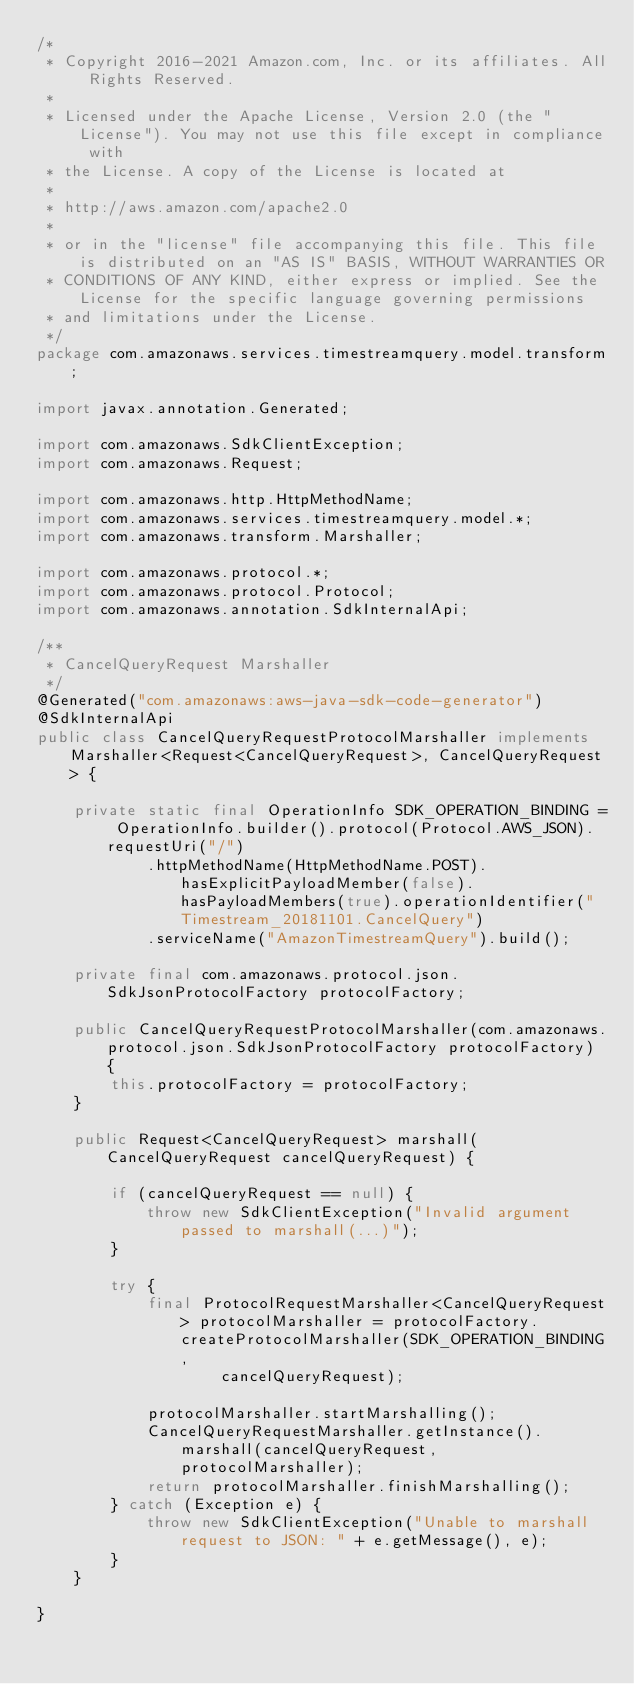Convert code to text. <code><loc_0><loc_0><loc_500><loc_500><_Java_>/*
 * Copyright 2016-2021 Amazon.com, Inc. or its affiliates. All Rights Reserved.
 * 
 * Licensed under the Apache License, Version 2.0 (the "License"). You may not use this file except in compliance with
 * the License. A copy of the License is located at
 * 
 * http://aws.amazon.com/apache2.0
 * 
 * or in the "license" file accompanying this file. This file is distributed on an "AS IS" BASIS, WITHOUT WARRANTIES OR
 * CONDITIONS OF ANY KIND, either express or implied. See the License for the specific language governing permissions
 * and limitations under the License.
 */
package com.amazonaws.services.timestreamquery.model.transform;

import javax.annotation.Generated;

import com.amazonaws.SdkClientException;
import com.amazonaws.Request;

import com.amazonaws.http.HttpMethodName;
import com.amazonaws.services.timestreamquery.model.*;
import com.amazonaws.transform.Marshaller;

import com.amazonaws.protocol.*;
import com.amazonaws.protocol.Protocol;
import com.amazonaws.annotation.SdkInternalApi;

/**
 * CancelQueryRequest Marshaller
 */
@Generated("com.amazonaws:aws-java-sdk-code-generator")
@SdkInternalApi
public class CancelQueryRequestProtocolMarshaller implements Marshaller<Request<CancelQueryRequest>, CancelQueryRequest> {

    private static final OperationInfo SDK_OPERATION_BINDING = OperationInfo.builder().protocol(Protocol.AWS_JSON).requestUri("/")
            .httpMethodName(HttpMethodName.POST).hasExplicitPayloadMember(false).hasPayloadMembers(true).operationIdentifier("Timestream_20181101.CancelQuery")
            .serviceName("AmazonTimestreamQuery").build();

    private final com.amazonaws.protocol.json.SdkJsonProtocolFactory protocolFactory;

    public CancelQueryRequestProtocolMarshaller(com.amazonaws.protocol.json.SdkJsonProtocolFactory protocolFactory) {
        this.protocolFactory = protocolFactory;
    }

    public Request<CancelQueryRequest> marshall(CancelQueryRequest cancelQueryRequest) {

        if (cancelQueryRequest == null) {
            throw new SdkClientException("Invalid argument passed to marshall(...)");
        }

        try {
            final ProtocolRequestMarshaller<CancelQueryRequest> protocolMarshaller = protocolFactory.createProtocolMarshaller(SDK_OPERATION_BINDING,
                    cancelQueryRequest);

            protocolMarshaller.startMarshalling();
            CancelQueryRequestMarshaller.getInstance().marshall(cancelQueryRequest, protocolMarshaller);
            return protocolMarshaller.finishMarshalling();
        } catch (Exception e) {
            throw new SdkClientException("Unable to marshall request to JSON: " + e.getMessage(), e);
        }
    }

}
</code> 